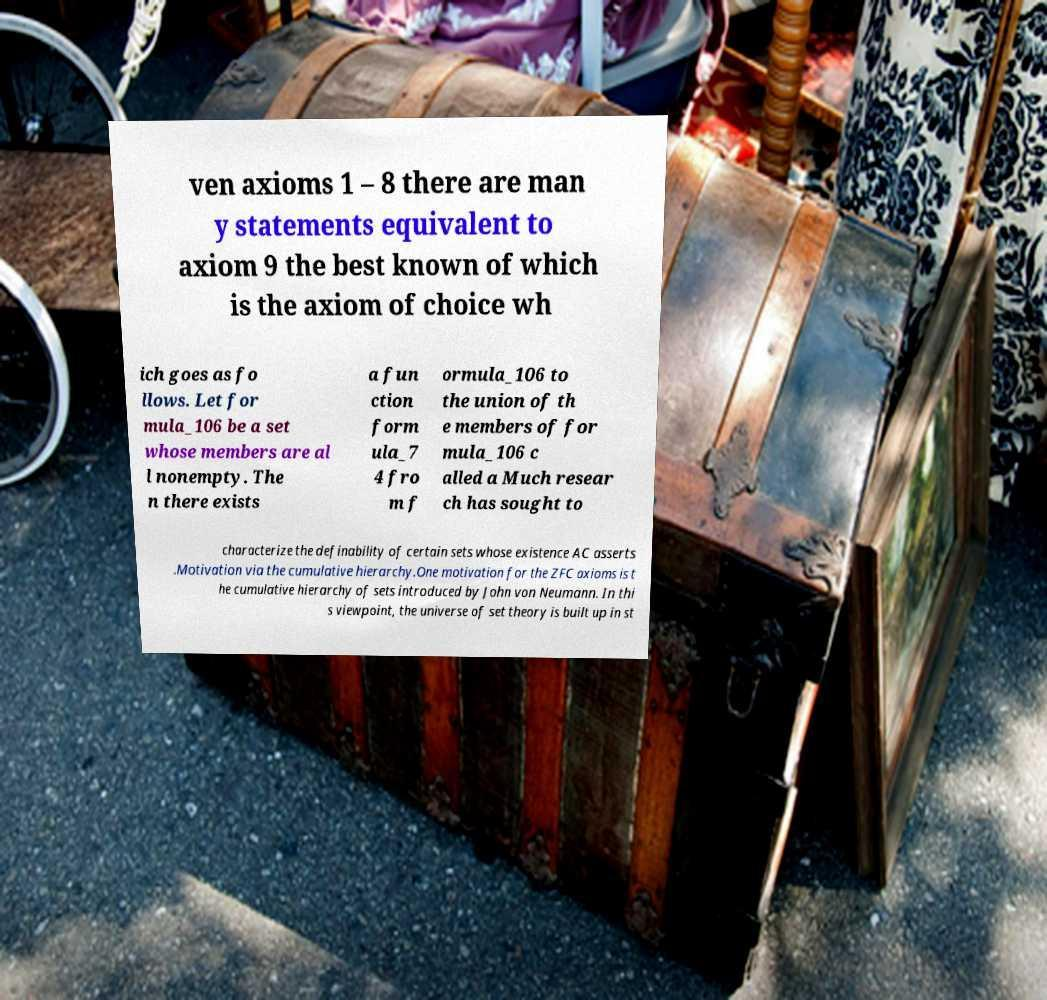Could you assist in decoding the text presented in this image and type it out clearly? ven axioms 1 – 8 there are man y statements equivalent to axiom 9 the best known of which is the axiom of choice wh ich goes as fo llows. Let for mula_106 be a set whose members are al l nonempty. The n there exists a fun ction form ula_7 4 fro m f ormula_106 to the union of th e members of for mula_106 c alled a Much resear ch has sought to characterize the definability of certain sets whose existence AC asserts .Motivation via the cumulative hierarchy.One motivation for the ZFC axioms is t he cumulative hierarchy of sets introduced by John von Neumann. In thi s viewpoint, the universe of set theory is built up in st 